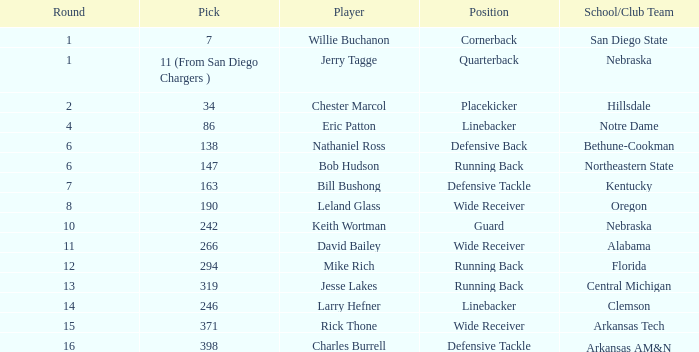Which option features a school or club team from kentucky? 163.0. 